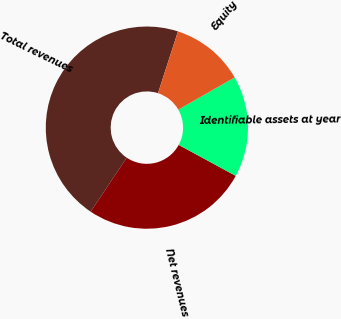Convert chart to OTSL. <chart><loc_0><loc_0><loc_500><loc_500><pie_chart><fcel>Total revenues<fcel>Net revenues<fcel>Identifiable assets at year<fcel>Equity<nl><fcel>45.59%<fcel>26.47%<fcel>16.18%<fcel>11.76%<nl></chart> 